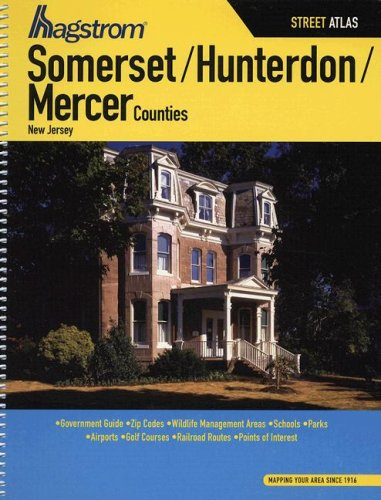Can you provide specific features that make this atlas useful for travelers? The atlas includes detailed street maps, zip codes, important government contacts, and listings of essential services such as hospitals and police stations, making it invaluable for both residents and visitors planning travel or relocation. 